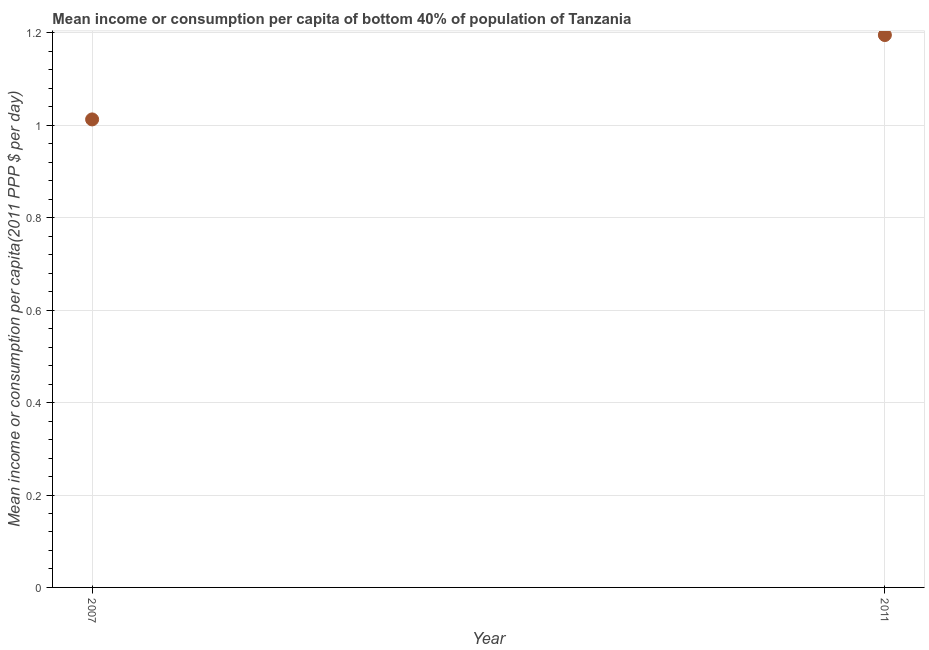What is the mean income or consumption in 2007?
Provide a succinct answer. 1.01. Across all years, what is the maximum mean income or consumption?
Offer a very short reply. 1.2. Across all years, what is the minimum mean income or consumption?
Your answer should be compact. 1.01. In which year was the mean income or consumption maximum?
Offer a terse response. 2011. In which year was the mean income or consumption minimum?
Provide a succinct answer. 2007. What is the sum of the mean income or consumption?
Keep it short and to the point. 2.21. What is the difference between the mean income or consumption in 2007 and 2011?
Your answer should be compact. -0.18. What is the average mean income or consumption per year?
Your response must be concise. 1.1. What is the median mean income or consumption?
Your answer should be compact. 1.1. Do a majority of the years between 2011 and 2007 (inclusive) have mean income or consumption greater than 0.92 $?
Give a very brief answer. No. What is the ratio of the mean income or consumption in 2007 to that in 2011?
Give a very brief answer. 0.85. In how many years, is the mean income or consumption greater than the average mean income or consumption taken over all years?
Provide a short and direct response. 1. How many dotlines are there?
Ensure brevity in your answer.  1. How many years are there in the graph?
Your answer should be very brief. 2. Does the graph contain any zero values?
Keep it short and to the point. No. Does the graph contain grids?
Your answer should be compact. Yes. What is the title of the graph?
Provide a short and direct response. Mean income or consumption per capita of bottom 40% of population of Tanzania. What is the label or title of the X-axis?
Provide a short and direct response. Year. What is the label or title of the Y-axis?
Keep it short and to the point. Mean income or consumption per capita(2011 PPP $ per day). What is the Mean income or consumption per capita(2011 PPP $ per day) in 2007?
Offer a very short reply. 1.01. What is the Mean income or consumption per capita(2011 PPP $ per day) in 2011?
Offer a very short reply. 1.2. What is the difference between the Mean income or consumption per capita(2011 PPP $ per day) in 2007 and 2011?
Your response must be concise. -0.18. What is the ratio of the Mean income or consumption per capita(2011 PPP $ per day) in 2007 to that in 2011?
Give a very brief answer. 0.85. 